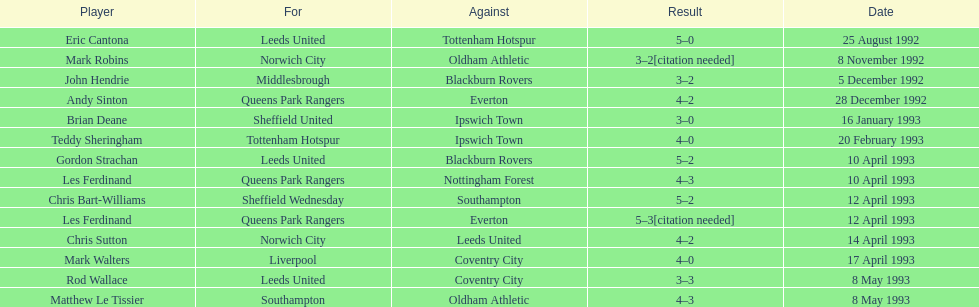For which team does john hendrie play? Middlesbrough. 